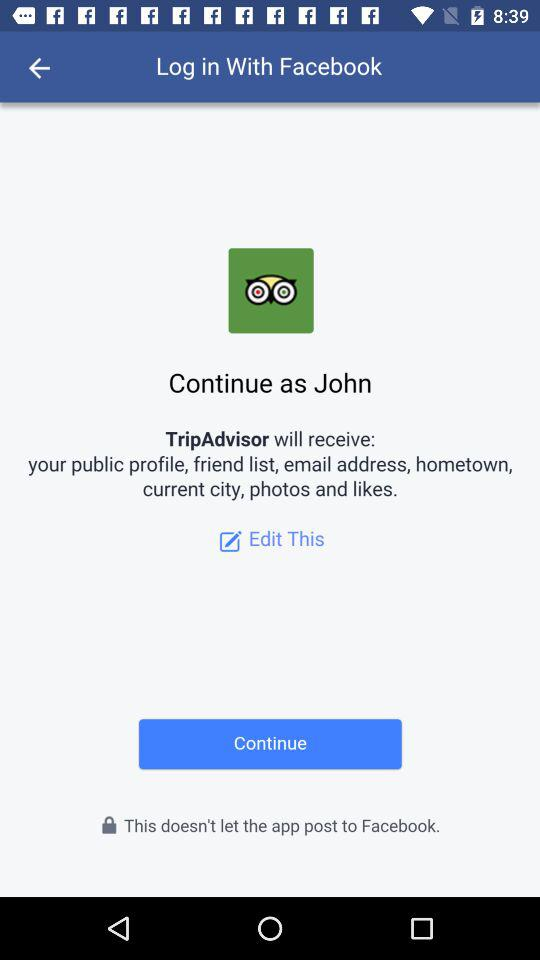What is the user name? The user name is John. 